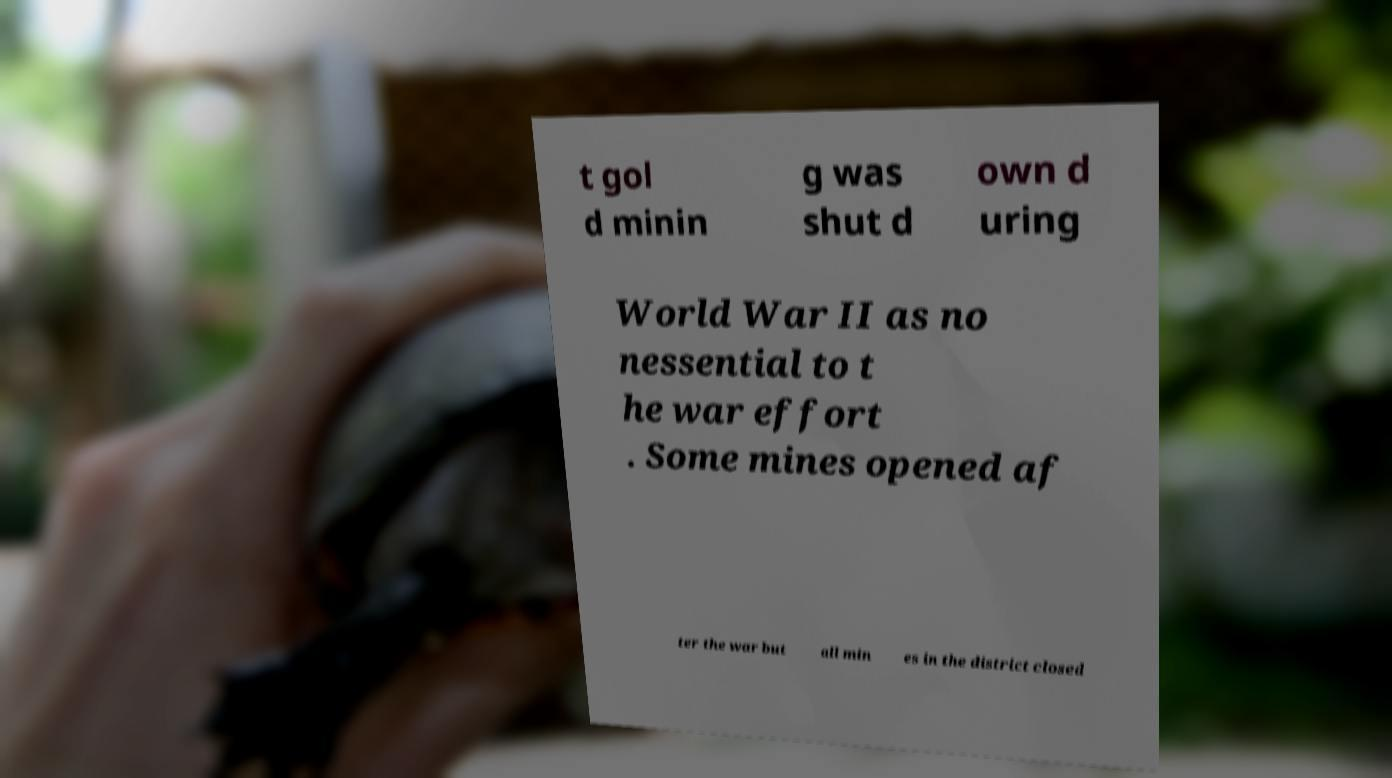What messages or text are displayed in this image? I need them in a readable, typed format. t gol d minin g was shut d own d uring World War II as no nessential to t he war effort . Some mines opened af ter the war but all min es in the district closed 